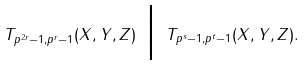<formula> <loc_0><loc_0><loc_500><loc_500>T _ { p ^ { 2 r } - 1 , p ^ { r } - 1 } ( X , Y , Z ) \ \Big | \ T _ { p ^ { s } - 1 , p ^ { t } - 1 } ( X , Y , Z ) .</formula> 